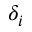Convert formula to latex. <formula><loc_0><loc_0><loc_500><loc_500>\delta _ { i }</formula> 